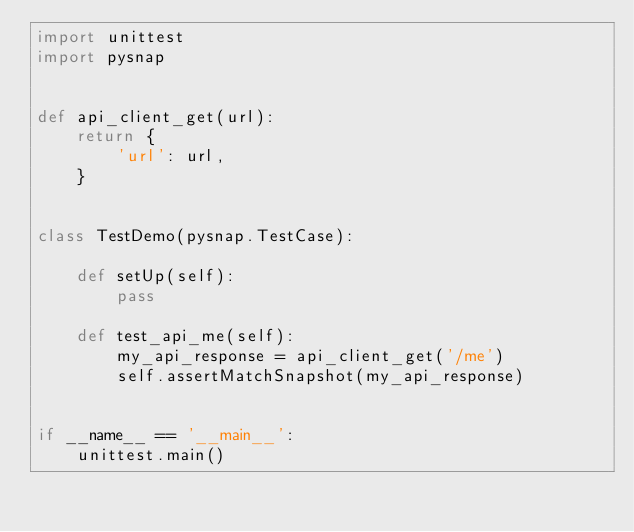Convert code to text. <code><loc_0><loc_0><loc_500><loc_500><_Python_>import unittest
import pysnap


def api_client_get(url):
    return {
        'url': url,
    }


class TestDemo(pysnap.TestCase):

    def setUp(self):
        pass

    def test_api_me(self):
        my_api_response = api_client_get('/me')
        self.assertMatchSnapshot(my_api_response)


if __name__ == '__main__':
    unittest.main()
</code> 